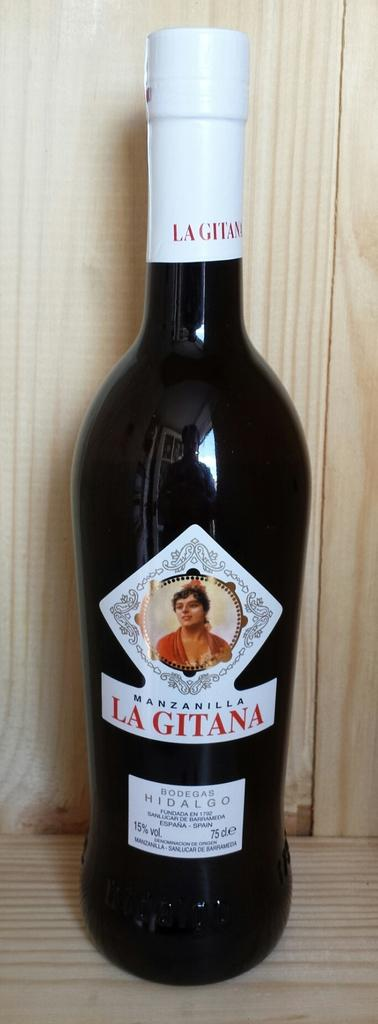<image>
Give a short and clear explanation of the subsequent image. the word gitana that is on a wine bottle 